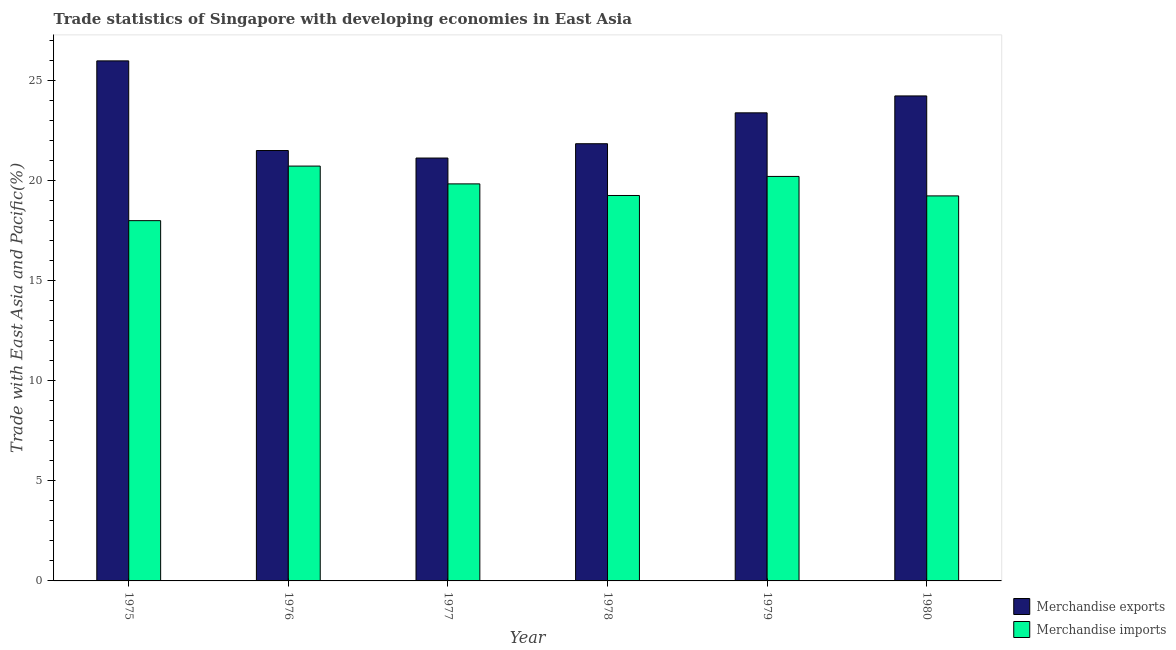How many different coloured bars are there?
Your answer should be compact. 2. What is the label of the 5th group of bars from the left?
Provide a succinct answer. 1979. In how many cases, is the number of bars for a given year not equal to the number of legend labels?
Ensure brevity in your answer.  0. What is the merchandise imports in 1977?
Provide a short and direct response. 19.84. Across all years, what is the maximum merchandise imports?
Provide a short and direct response. 20.73. Across all years, what is the minimum merchandise imports?
Make the answer very short. 18. In which year was the merchandise imports maximum?
Ensure brevity in your answer.  1976. In which year was the merchandise imports minimum?
Offer a very short reply. 1975. What is the total merchandise exports in the graph?
Keep it short and to the point. 138.1. What is the difference between the merchandise exports in 1978 and that in 1979?
Your answer should be very brief. -1.54. What is the difference between the merchandise imports in 1976 and the merchandise exports in 1975?
Ensure brevity in your answer.  2.73. What is the average merchandise exports per year?
Provide a succinct answer. 23.02. In how many years, is the merchandise imports greater than 6 %?
Provide a succinct answer. 6. What is the ratio of the merchandise exports in 1975 to that in 1977?
Give a very brief answer. 1.23. What is the difference between the highest and the second highest merchandise imports?
Offer a very short reply. 0.52. What is the difference between the highest and the lowest merchandise imports?
Provide a succinct answer. 2.73. What does the 2nd bar from the left in 1979 represents?
Give a very brief answer. Merchandise imports. How many years are there in the graph?
Offer a terse response. 6. Does the graph contain grids?
Keep it short and to the point. No. Where does the legend appear in the graph?
Ensure brevity in your answer.  Bottom right. How many legend labels are there?
Make the answer very short. 2. What is the title of the graph?
Make the answer very short. Trade statistics of Singapore with developing economies in East Asia. Does "Residents" appear as one of the legend labels in the graph?
Ensure brevity in your answer.  No. What is the label or title of the Y-axis?
Make the answer very short. Trade with East Asia and Pacific(%). What is the Trade with East Asia and Pacific(%) of Merchandise exports in 1975?
Offer a terse response. 25.99. What is the Trade with East Asia and Pacific(%) of Merchandise imports in 1975?
Your answer should be very brief. 18. What is the Trade with East Asia and Pacific(%) of Merchandise exports in 1976?
Your answer should be compact. 21.51. What is the Trade with East Asia and Pacific(%) of Merchandise imports in 1976?
Your answer should be very brief. 20.73. What is the Trade with East Asia and Pacific(%) in Merchandise exports in 1977?
Your answer should be compact. 21.13. What is the Trade with East Asia and Pacific(%) in Merchandise imports in 1977?
Provide a short and direct response. 19.84. What is the Trade with East Asia and Pacific(%) of Merchandise exports in 1978?
Offer a terse response. 21.85. What is the Trade with East Asia and Pacific(%) of Merchandise imports in 1978?
Your answer should be very brief. 19.26. What is the Trade with East Asia and Pacific(%) of Merchandise exports in 1979?
Provide a short and direct response. 23.39. What is the Trade with East Asia and Pacific(%) in Merchandise imports in 1979?
Offer a very short reply. 20.21. What is the Trade with East Asia and Pacific(%) of Merchandise exports in 1980?
Provide a succinct answer. 24.24. What is the Trade with East Asia and Pacific(%) in Merchandise imports in 1980?
Offer a very short reply. 19.24. Across all years, what is the maximum Trade with East Asia and Pacific(%) of Merchandise exports?
Make the answer very short. 25.99. Across all years, what is the maximum Trade with East Asia and Pacific(%) in Merchandise imports?
Your answer should be compact. 20.73. Across all years, what is the minimum Trade with East Asia and Pacific(%) in Merchandise exports?
Your answer should be compact. 21.13. Across all years, what is the minimum Trade with East Asia and Pacific(%) of Merchandise imports?
Offer a terse response. 18. What is the total Trade with East Asia and Pacific(%) in Merchandise exports in the graph?
Keep it short and to the point. 138.1. What is the total Trade with East Asia and Pacific(%) in Merchandise imports in the graph?
Your answer should be very brief. 117.29. What is the difference between the Trade with East Asia and Pacific(%) in Merchandise exports in 1975 and that in 1976?
Provide a short and direct response. 4.48. What is the difference between the Trade with East Asia and Pacific(%) of Merchandise imports in 1975 and that in 1976?
Your response must be concise. -2.73. What is the difference between the Trade with East Asia and Pacific(%) in Merchandise exports in 1975 and that in 1977?
Your answer should be compact. 4.86. What is the difference between the Trade with East Asia and Pacific(%) of Merchandise imports in 1975 and that in 1977?
Your response must be concise. -1.84. What is the difference between the Trade with East Asia and Pacific(%) in Merchandise exports in 1975 and that in 1978?
Your answer should be compact. 4.14. What is the difference between the Trade with East Asia and Pacific(%) in Merchandise imports in 1975 and that in 1978?
Provide a short and direct response. -1.26. What is the difference between the Trade with East Asia and Pacific(%) of Merchandise exports in 1975 and that in 1979?
Your response must be concise. 2.6. What is the difference between the Trade with East Asia and Pacific(%) in Merchandise imports in 1975 and that in 1979?
Offer a very short reply. -2.21. What is the difference between the Trade with East Asia and Pacific(%) of Merchandise exports in 1975 and that in 1980?
Provide a short and direct response. 1.75. What is the difference between the Trade with East Asia and Pacific(%) of Merchandise imports in 1975 and that in 1980?
Your response must be concise. -1.24. What is the difference between the Trade with East Asia and Pacific(%) of Merchandise exports in 1976 and that in 1977?
Ensure brevity in your answer.  0.38. What is the difference between the Trade with East Asia and Pacific(%) of Merchandise imports in 1976 and that in 1977?
Make the answer very short. 0.89. What is the difference between the Trade with East Asia and Pacific(%) of Merchandise exports in 1976 and that in 1978?
Ensure brevity in your answer.  -0.34. What is the difference between the Trade with East Asia and Pacific(%) of Merchandise imports in 1976 and that in 1978?
Make the answer very short. 1.47. What is the difference between the Trade with East Asia and Pacific(%) of Merchandise exports in 1976 and that in 1979?
Offer a terse response. -1.88. What is the difference between the Trade with East Asia and Pacific(%) in Merchandise imports in 1976 and that in 1979?
Your response must be concise. 0.52. What is the difference between the Trade with East Asia and Pacific(%) in Merchandise exports in 1976 and that in 1980?
Your answer should be compact. -2.73. What is the difference between the Trade with East Asia and Pacific(%) of Merchandise imports in 1976 and that in 1980?
Offer a terse response. 1.49. What is the difference between the Trade with East Asia and Pacific(%) of Merchandise exports in 1977 and that in 1978?
Provide a succinct answer. -0.72. What is the difference between the Trade with East Asia and Pacific(%) in Merchandise imports in 1977 and that in 1978?
Your response must be concise. 0.58. What is the difference between the Trade with East Asia and Pacific(%) in Merchandise exports in 1977 and that in 1979?
Keep it short and to the point. -2.26. What is the difference between the Trade with East Asia and Pacific(%) in Merchandise imports in 1977 and that in 1979?
Your response must be concise. -0.37. What is the difference between the Trade with East Asia and Pacific(%) of Merchandise exports in 1977 and that in 1980?
Offer a terse response. -3.1. What is the difference between the Trade with East Asia and Pacific(%) in Merchandise imports in 1977 and that in 1980?
Provide a succinct answer. 0.6. What is the difference between the Trade with East Asia and Pacific(%) in Merchandise exports in 1978 and that in 1979?
Provide a short and direct response. -1.54. What is the difference between the Trade with East Asia and Pacific(%) in Merchandise imports in 1978 and that in 1979?
Your answer should be very brief. -0.95. What is the difference between the Trade with East Asia and Pacific(%) of Merchandise exports in 1978 and that in 1980?
Your response must be concise. -2.39. What is the difference between the Trade with East Asia and Pacific(%) in Merchandise imports in 1978 and that in 1980?
Ensure brevity in your answer.  0.02. What is the difference between the Trade with East Asia and Pacific(%) of Merchandise exports in 1979 and that in 1980?
Keep it short and to the point. -0.84. What is the difference between the Trade with East Asia and Pacific(%) in Merchandise imports in 1979 and that in 1980?
Provide a short and direct response. 0.97. What is the difference between the Trade with East Asia and Pacific(%) of Merchandise exports in 1975 and the Trade with East Asia and Pacific(%) of Merchandise imports in 1976?
Ensure brevity in your answer.  5.26. What is the difference between the Trade with East Asia and Pacific(%) in Merchandise exports in 1975 and the Trade with East Asia and Pacific(%) in Merchandise imports in 1977?
Make the answer very short. 6.15. What is the difference between the Trade with East Asia and Pacific(%) of Merchandise exports in 1975 and the Trade with East Asia and Pacific(%) of Merchandise imports in 1978?
Your response must be concise. 6.73. What is the difference between the Trade with East Asia and Pacific(%) in Merchandise exports in 1975 and the Trade with East Asia and Pacific(%) in Merchandise imports in 1979?
Offer a very short reply. 5.77. What is the difference between the Trade with East Asia and Pacific(%) of Merchandise exports in 1975 and the Trade with East Asia and Pacific(%) of Merchandise imports in 1980?
Give a very brief answer. 6.75. What is the difference between the Trade with East Asia and Pacific(%) in Merchandise exports in 1976 and the Trade with East Asia and Pacific(%) in Merchandise imports in 1977?
Provide a succinct answer. 1.67. What is the difference between the Trade with East Asia and Pacific(%) in Merchandise exports in 1976 and the Trade with East Asia and Pacific(%) in Merchandise imports in 1978?
Provide a short and direct response. 2.25. What is the difference between the Trade with East Asia and Pacific(%) of Merchandise exports in 1976 and the Trade with East Asia and Pacific(%) of Merchandise imports in 1979?
Your response must be concise. 1.3. What is the difference between the Trade with East Asia and Pacific(%) in Merchandise exports in 1976 and the Trade with East Asia and Pacific(%) in Merchandise imports in 1980?
Give a very brief answer. 2.27. What is the difference between the Trade with East Asia and Pacific(%) in Merchandise exports in 1977 and the Trade with East Asia and Pacific(%) in Merchandise imports in 1978?
Ensure brevity in your answer.  1.87. What is the difference between the Trade with East Asia and Pacific(%) of Merchandise exports in 1977 and the Trade with East Asia and Pacific(%) of Merchandise imports in 1979?
Your answer should be very brief. 0.92. What is the difference between the Trade with East Asia and Pacific(%) of Merchandise exports in 1977 and the Trade with East Asia and Pacific(%) of Merchandise imports in 1980?
Make the answer very short. 1.89. What is the difference between the Trade with East Asia and Pacific(%) of Merchandise exports in 1978 and the Trade with East Asia and Pacific(%) of Merchandise imports in 1979?
Provide a short and direct response. 1.63. What is the difference between the Trade with East Asia and Pacific(%) of Merchandise exports in 1978 and the Trade with East Asia and Pacific(%) of Merchandise imports in 1980?
Ensure brevity in your answer.  2.61. What is the difference between the Trade with East Asia and Pacific(%) of Merchandise exports in 1979 and the Trade with East Asia and Pacific(%) of Merchandise imports in 1980?
Your answer should be very brief. 4.15. What is the average Trade with East Asia and Pacific(%) of Merchandise exports per year?
Keep it short and to the point. 23.02. What is the average Trade with East Asia and Pacific(%) of Merchandise imports per year?
Make the answer very short. 19.55. In the year 1975, what is the difference between the Trade with East Asia and Pacific(%) in Merchandise exports and Trade with East Asia and Pacific(%) in Merchandise imports?
Provide a succinct answer. 7.98. In the year 1976, what is the difference between the Trade with East Asia and Pacific(%) of Merchandise exports and Trade with East Asia and Pacific(%) of Merchandise imports?
Provide a succinct answer. 0.78. In the year 1977, what is the difference between the Trade with East Asia and Pacific(%) of Merchandise exports and Trade with East Asia and Pacific(%) of Merchandise imports?
Your response must be concise. 1.29. In the year 1978, what is the difference between the Trade with East Asia and Pacific(%) in Merchandise exports and Trade with East Asia and Pacific(%) in Merchandise imports?
Ensure brevity in your answer.  2.59. In the year 1979, what is the difference between the Trade with East Asia and Pacific(%) of Merchandise exports and Trade with East Asia and Pacific(%) of Merchandise imports?
Your answer should be very brief. 3.18. In the year 1980, what is the difference between the Trade with East Asia and Pacific(%) of Merchandise exports and Trade with East Asia and Pacific(%) of Merchandise imports?
Offer a very short reply. 5. What is the ratio of the Trade with East Asia and Pacific(%) of Merchandise exports in 1975 to that in 1976?
Your answer should be very brief. 1.21. What is the ratio of the Trade with East Asia and Pacific(%) of Merchandise imports in 1975 to that in 1976?
Make the answer very short. 0.87. What is the ratio of the Trade with East Asia and Pacific(%) of Merchandise exports in 1975 to that in 1977?
Provide a succinct answer. 1.23. What is the ratio of the Trade with East Asia and Pacific(%) in Merchandise imports in 1975 to that in 1977?
Ensure brevity in your answer.  0.91. What is the ratio of the Trade with East Asia and Pacific(%) in Merchandise exports in 1975 to that in 1978?
Provide a short and direct response. 1.19. What is the ratio of the Trade with East Asia and Pacific(%) in Merchandise imports in 1975 to that in 1978?
Provide a short and direct response. 0.93. What is the ratio of the Trade with East Asia and Pacific(%) in Merchandise exports in 1975 to that in 1979?
Your response must be concise. 1.11. What is the ratio of the Trade with East Asia and Pacific(%) in Merchandise imports in 1975 to that in 1979?
Make the answer very short. 0.89. What is the ratio of the Trade with East Asia and Pacific(%) of Merchandise exports in 1975 to that in 1980?
Ensure brevity in your answer.  1.07. What is the ratio of the Trade with East Asia and Pacific(%) of Merchandise imports in 1975 to that in 1980?
Keep it short and to the point. 0.94. What is the ratio of the Trade with East Asia and Pacific(%) in Merchandise exports in 1976 to that in 1977?
Your response must be concise. 1.02. What is the ratio of the Trade with East Asia and Pacific(%) in Merchandise imports in 1976 to that in 1977?
Offer a terse response. 1.04. What is the ratio of the Trade with East Asia and Pacific(%) of Merchandise exports in 1976 to that in 1978?
Provide a succinct answer. 0.98. What is the ratio of the Trade with East Asia and Pacific(%) of Merchandise imports in 1976 to that in 1978?
Make the answer very short. 1.08. What is the ratio of the Trade with East Asia and Pacific(%) of Merchandise exports in 1976 to that in 1979?
Provide a short and direct response. 0.92. What is the ratio of the Trade with East Asia and Pacific(%) of Merchandise imports in 1976 to that in 1979?
Your answer should be compact. 1.03. What is the ratio of the Trade with East Asia and Pacific(%) in Merchandise exports in 1976 to that in 1980?
Ensure brevity in your answer.  0.89. What is the ratio of the Trade with East Asia and Pacific(%) in Merchandise imports in 1976 to that in 1980?
Offer a terse response. 1.08. What is the ratio of the Trade with East Asia and Pacific(%) of Merchandise exports in 1977 to that in 1978?
Offer a very short reply. 0.97. What is the ratio of the Trade with East Asia and Pacific(%) of Merchandise imports in 1977 to that in 1978?
Give a very brief answer. 1.03. What is the ratio of the Trade with East Asia and Pacific(%) in Merchandise exports in 1977 to that in 1979?
Your response must be concise. 0.9. What is the ratio of the Trade with East Asia and Pacific(%) of Merchandise imports in 1977 to that in 1979?
Ensure brevity in your answer.  0.98. What is the ratio of the Trade with East Asia and Pacific(%) in Merchandise exports in 1977 to that in 1980?
Your answer should be compact. 0.87. What is the ratio of the Trade with East Asia and Pacific(%) in Merchandise imports in 1977 to that in 1980?
Provide a succinct answer. 1.03. What is the ratio of the Trade with East Asia and Pacific(%) of Merchandise exports in 1978 to that in 1979?
Ensure brevity in your answer.  0.93. What is the ratio of the Trade with East Asia and Pacific(%) of Merchandise imports in 1978 to that in 1979?
Provide a succinct answer. 0.95. What is the ratio of the Trade with East Asia and Pacific(%) of Merchandise exports in 1978 to that in 1980?
Give a very brief answer. 0.9. What is the ratio of the Trade with East Asia and Pacific(%) of Merchandise exports in 1979 to that in 1980?
Provide a succinct answer. 0.97. What is the ratio of the Trade with East Asia and Pacific(%) of Merchandise imports in 1979 to that in 1980?
Provide a short and direct response. 1.05. What is the difference between the highest and the second highest Trade with East Asia and Pacific(%) in Merchandise exports?
Offer a very short reply. 1.75. What is the difference between the highest and the second highest Trade with East Asia and Pacific(%) of Merchandise imports?
Your answer should be compact. 0.52. What is the difference between the highest and the lowest Trade with East Asia and Pacific(%) in Merchandise exports?
Provide a succinct answer. 4.86. What is the difference between the highest and the lowest Trade with East Asia and Pacific(%) in Merchandise imports?
Keep it short and to the point. 2.73. 